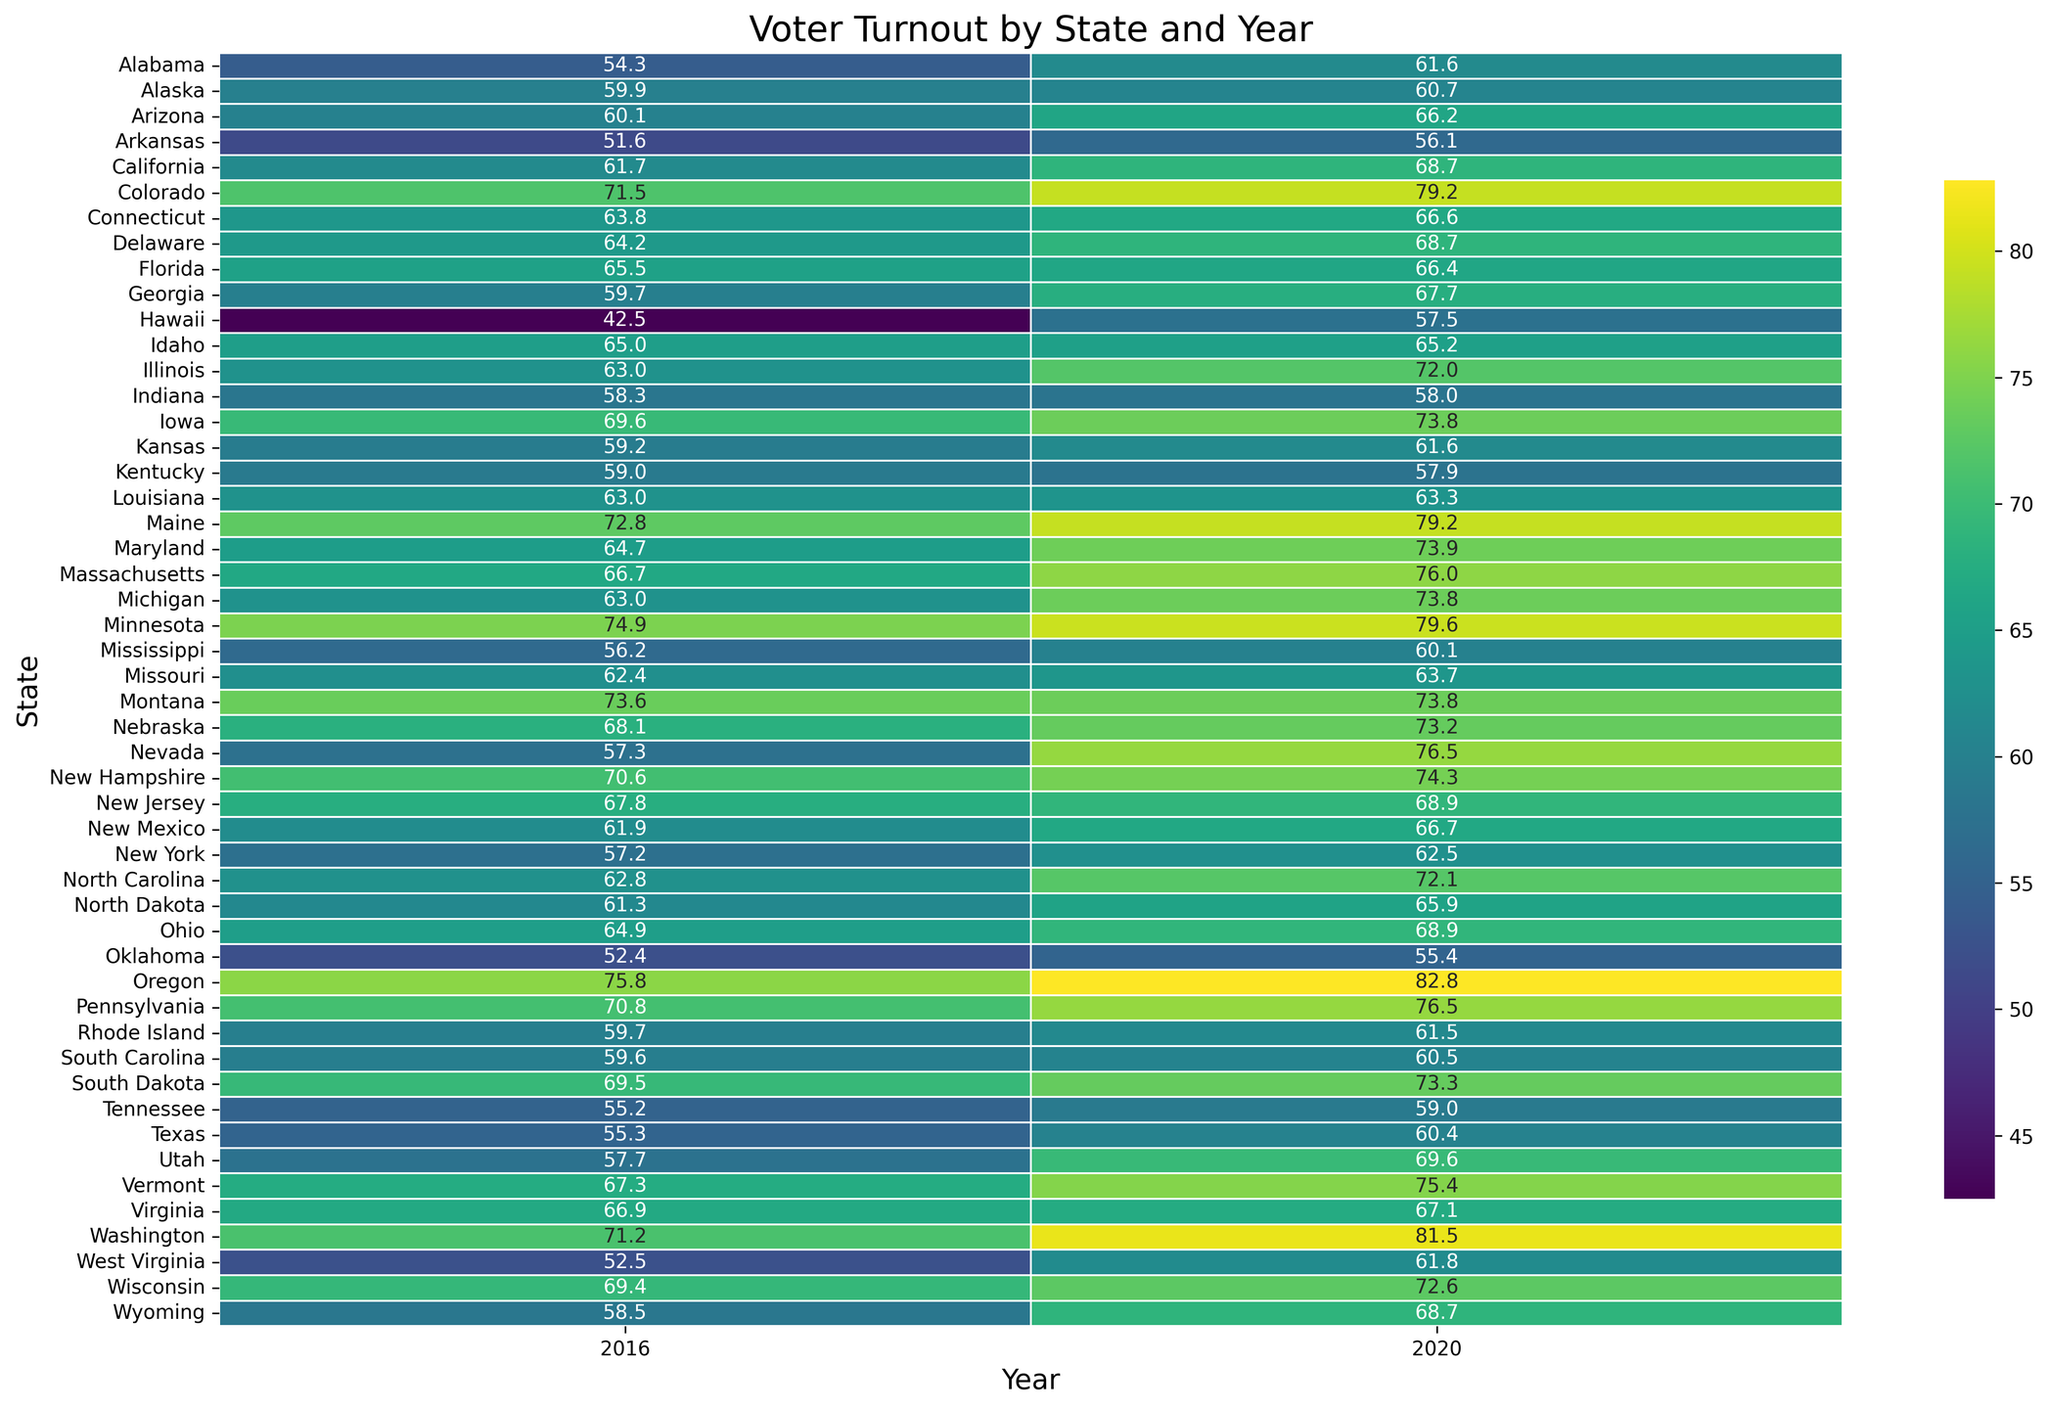What's the state with the highest voter turnout in 2020? The heatmap shows the voter turnout values for each state by year, and the highest value can be identified visually. In 2020, Oregon has the highest voter turnout of 82.8%.
Answer: Oregon How does the voter turnout in Georgia compare between 2016 and 2020? By visually identifying Georgia in the heatmap and comparing the corresponding cells for 2016 and 2020, we can see that the voter turnout increased from 59.7% in 2016 to 67.7% in 2020.
Answer: Increased from 59.7% to 67.7% Which states had lower voter turnout in 2020 compared to 2016? Scan the heatmap for states where the 2020 voter turnout value is lower than the 2016 value. These states include Indiana, Hawaii, and Wisconsin.
Answer: Indiana, Hawaii, and Wisconsin What is the average voter turnout for 2020 across all states? Add up all the voter turnout values for 2020 and divide by the number of states. The total is (61.6 + 60.7 + 66.2 + 56.1 + 68.7 + 79.2 + 66.6 + 68.7 + 66.4 + 67.7 + 57.5 + 65.2 + 72.0 + 58.0 + 73.8 + 61.6 + 57.9 + 63.3 + 79.2 + 73.9 + 76.0 + 73.8 + 79.6 + 60.1 + 63.7 + 73.8 + 73.2 + 76.5 + 68.9 + 66.7 + 62.5 + 72.1 + 65.9 + 68.9 + 55.4 + 82.8 + 76.5 + 61.5 + 60.5 + 73.3 + 59.0 + 60.4 + 69.6 + 75.4 + 67.1 + 81.5 + 61.8 + 72.6 + 68.7) / 50 = 67.9
Answer: 67.9% Identify a state where voter turnout remained almost the same between 2016 and 2020. By comparing the voter turnout values visually in the heatmap for both years, Illinois had values of 63.0 in 2016 and 72.0 in 2020, showing almost no change.
Answer: Illinois 